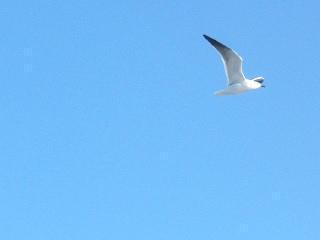How many birds are there?
Give a very brief answer. 1. 